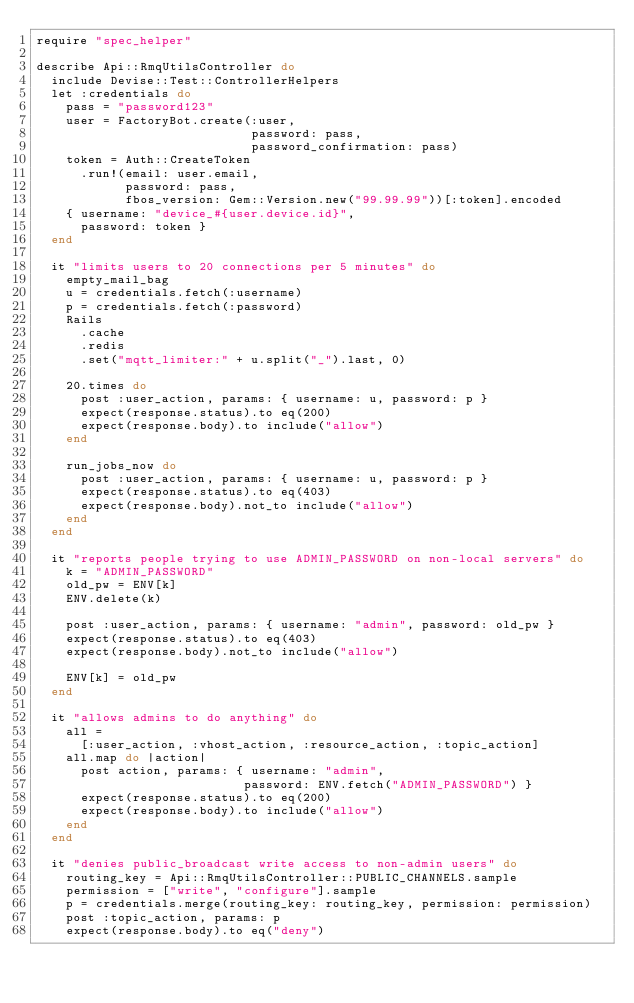Convert code to text. <code><loc_0><loc_0><loc_500><loc_500><_Ruby_>require "spec_helper"

describe Api::RmqUtilsController do
  include Devise::Test::ControllerHelpers
  let :credentials do
    pass = "password123"
    user = FactoryBot.create(:user,
                             password: pass,
                             password_confirmation: pass)
    token = Auth::CreateToken
      .run!(email: user.email,
            password: pass,
            fbos_version: Gem::Version.new("99.99.99"))[:token].encoded
    { username: "device_#{user.device.id}",
      password: token }
  end

  it "limits users to 20 connections per 5 minutes" do
    empty_mail_bag
    u = credentials.fetch(:username)
    p = credentials.fetch(:password)
    Rails
      .cache
      .redis
      .set("mqtt_limiter:" + u.split("_").last, 0)

    20.times do
      post :user_action, params: { username: u, password: p }
      expect(response.status).to eq(200)
      expect(response.body).to include("allow")
    end

    run_jobs_now do
      post :user_action, params: { username: u, password: p }
      expect(response.status).to eq(403)
      expect(response.body).not_to include("allow")
    end
  end

  it "reports people trying to use ADMIN_PASSWORD on non-local servers" do
    k = "ADMIN_PASSWORD"
    old_pw = ENV[k]
    ENV.delete(k)

    post :user_action, params: { username: "admin", password: old_pw }
    expect(response.status).to eq(403)
    expect(response.body).not_to include("allow")

    ENV[k] = old_pw
  end

  it "allows admins to do anything" do
    all =
      [:user_action, :vhost_action, :resource_action, :topic_action]
    all.map do |action|
      post action, params: { username: "admin",
                            password: ENV.fetch("ADMIN_PASSWORD") }
      expect(response.status).to eq(200)
      expect(response.body).to include("allow")
    end
  end

  it "denies public_broadcast write access to non-admin users" do
    routing_key = Api::RmqUtilsController::PUBLIC_CHANNELS.sample
    permission = ["write", "configure"].sample
    p = credentials.merge(routing_key: routing_key, permission: permission)
    post :topic_action, params: p
    expect(response.body).to eq("deny")</code> 